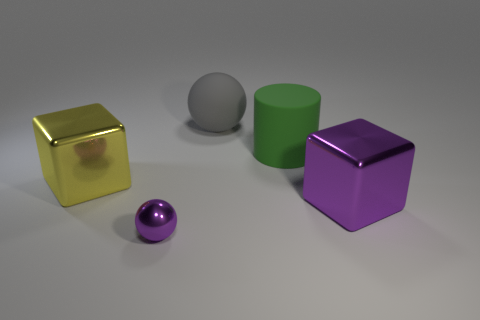Subtract all balls. How many objects are left? 3 Add 3 tiny metal balls. How many objects exist? 8 Subtract 1 spheres. How many spheres are left? 1 Subtract all small blue metal balls. Subtract all yellow objects. How many objects are left? 4 Add 3 green matte cylinders. How many green matte cylinders are left? 4 Add 1 yellow shiny blocks. How many yellow shiny blocks exist? 2 Subtract 0 yellow cylinders. How many objects are left? 5 Subtract all blue cubes. Subtract all blue spheres. How many cubes are left? 2 